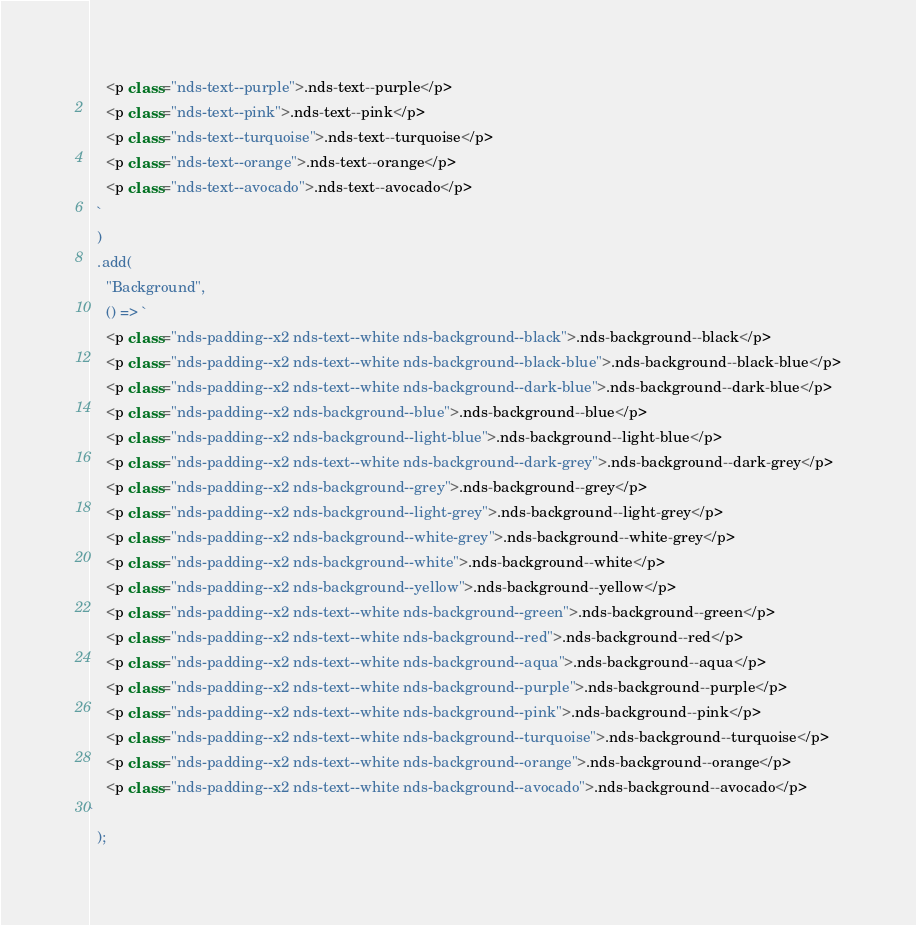Convert code to text. <code><loc_0><loc_0><loc_500><loc_500><_JavaScript_>    <p class="nds-text--purple">.nds-text--purple</p>
    <p class="nds-text--pink">.nds-text--pink</p>
    <p class="nds-text--turquoise">.nds-text--turquoise</p>
    <p class="nds-text--orange">.nds-text--orange</p>
    <p class="nds-text--avocado">.nds-text--avocado</p>
  `
  )
  .add(
    "Background",
    () => `
    <p class="nds-padding--x2 nds-text--white nds-background--black">.nds-background--black</p>
    <p class="nds-padding--x2 nds-text--white nds-background--black-blue">.nds-background--black-blue</p>
    <p class="nds-padding--x2 nds-text--white nds-background--dark-blue">.nds-background--dark-blue</p>
    <p class="nds-padding--x2 nds-background--blue">.nds-background--blue</p>
    <p class="nds-padding--x2 nds-background--light-blue">.nds-background--light-blue</p>
    <p class="nds-padding--x2 nds-text--white nds-background--dark-grey">.nds-background--dark-grey</p>
    <p class="nds-padding--x2 nds-background--grey">.nds-background--grey</p>
    <p class="nds-padding--x2 nds-background--light-grey">.nds-background--light-grey</p>
    <p class="nds-padding--x2 nds-background--white-grey">.nds-background--white-grey</p>
    <p class="nds-padding--x2 nds-background--white">.nds-background--white</p>
    <p class="nds-padding--x2 nds-background--yellow">.nds-background--yellow</p>
    <p class="nds-padding--x2 nds-text--white nds-background--green">.nds-background--green</p>
    <p class="nds-padding--x2 nds-text--white nds-background--red">.nds-background--red</p>
    <p class="nds-padding--x2 nds-text--white nds-background--aqua">.nds-background--aqua</p>
    <p class="nds-padding--x2 nds-text--white nds-background--purple">.nds-background--purple</p>
    <p class="nds-padding--x2 nds-text--white nds-background--pink">.nds-background--pink</p>
    <p class="nds-padding--x2 nds-text--white nds-background--turquoise">.nds-background--turquoise</p>
    <p class="nds-padding--x2 nds-text--white nds-background--orange">.nds-background--orange</p>
    <p class="nds-padding--x2 nds-text--white nds-background--avocado">.nds-background--avocado</p>
`
  );
</code> 